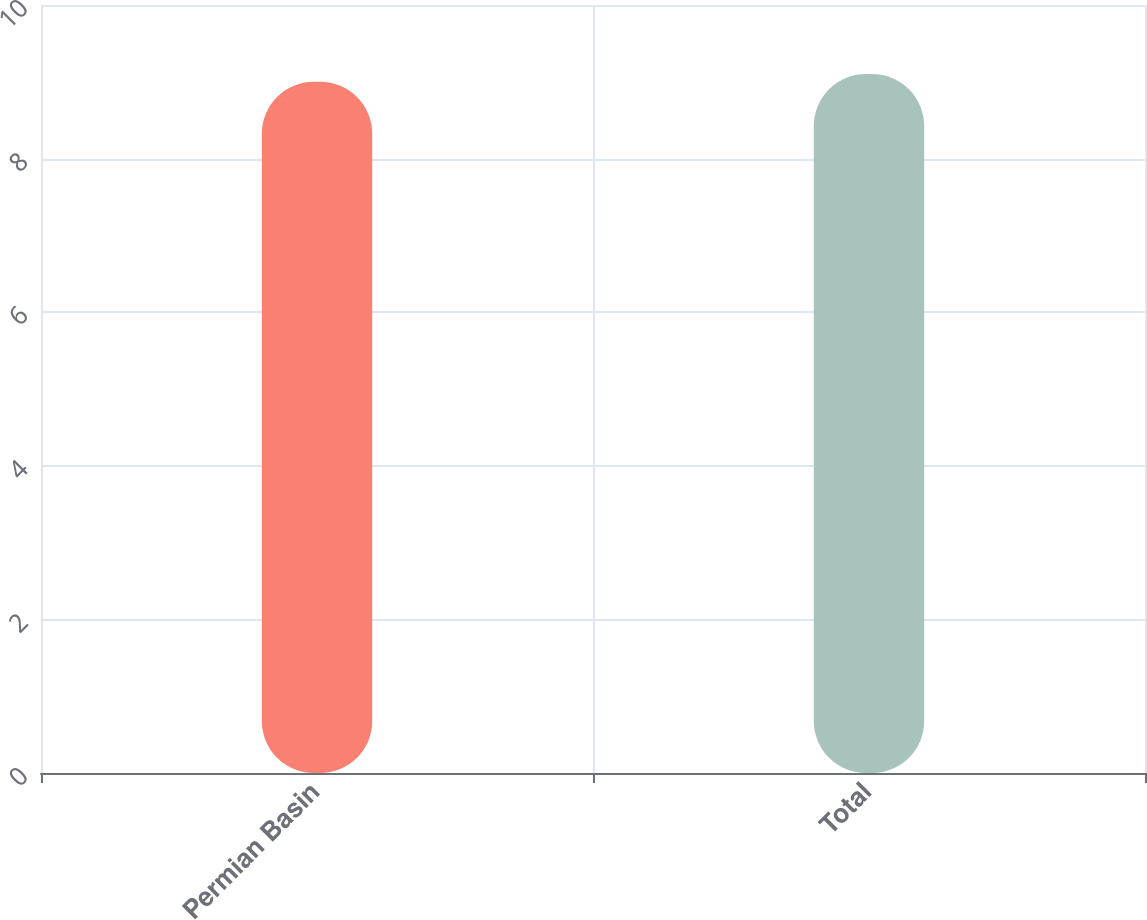<chart> <loc_0><loc_0><loc_500><loc_500><bar_chart><fcel>Permian Basin<fcel>Total<nl><fcel>9<fcel>9.1<nl></chart> 